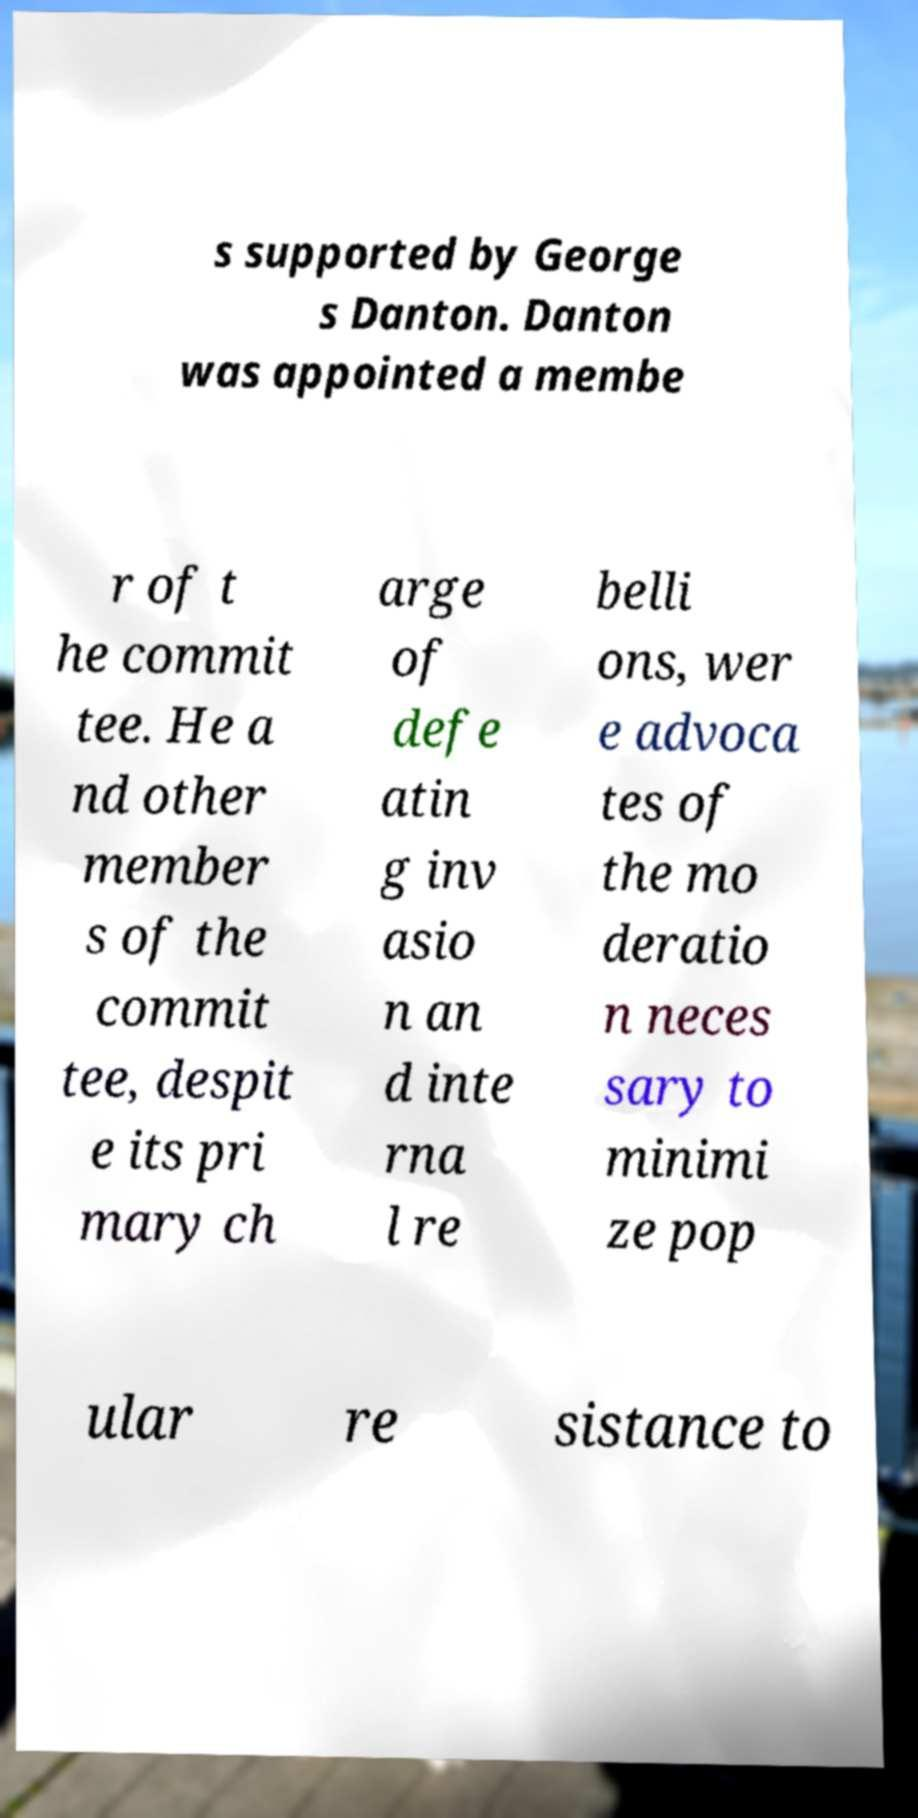Could you extract and type out the text from this image? s supported by George s Danton. Danton was appointed a membe r of t he commit tee. He a nd other member s of the commit tee, despit e its pri mary ch arge of defe atin g inv asio n an d inte rna l re belli ons, wer e advoca tes of the mo deratio n neces sary to minimi ze pop ular re sistance to 